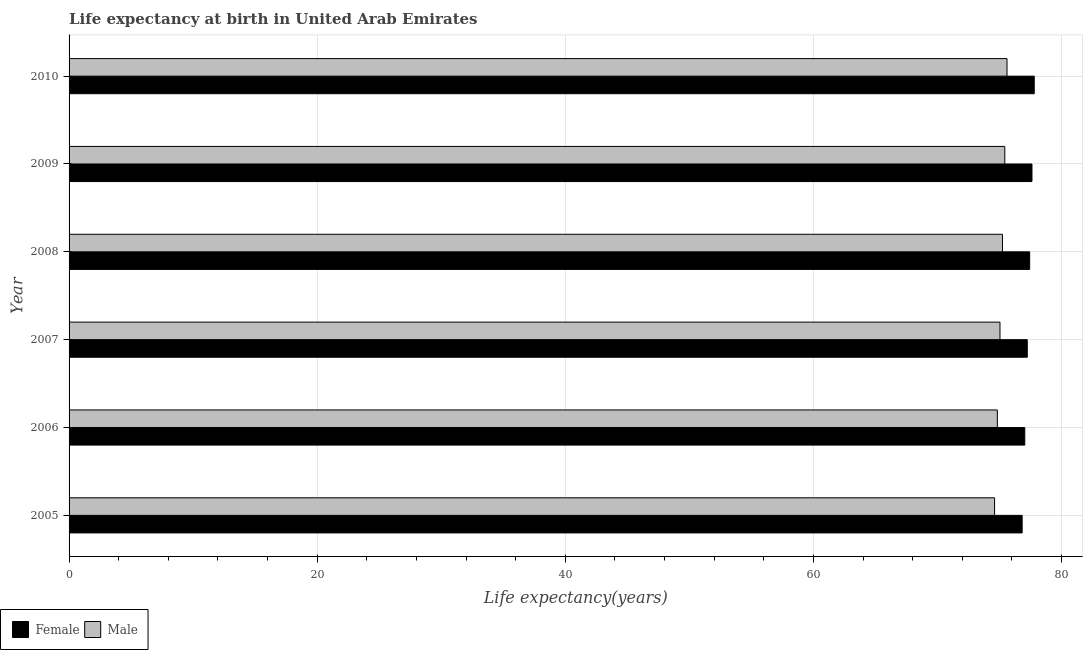In how many cases, is the number of bars for a given year not equal to the number of legend labels?
Make the answer very short. 0. What is the life expectancy(male) in 2008?
Provide a short and direct response. 75.24. Across all years, what is the maximum life expectancy(male)?
Ensure brevity in your answer.  75.61. Across all years, what is the minimum life expectancy(male)?
Make the answer very short. 74.6. In which year was the life expectancy(male) maximum?
Keep it short and to the point. 2010. In which year was the life expectancy(male) minimum?
Give a very brief answer. 2005. What is the total life expectancy(female) in the graph?
Offer a terse response. 463.95. What is the difference between the life expectancy(male) in 2005 and that in 2006?
Make the answer very short. -0.22. What is the difference between the life expectancy(male) in 2006 and the life expectancy(female) in 2007?
Keep it short and to the point. -2.41. What is the average life expectancy(male) per year?
Keep it short and to the point. 75.12. In the year 2005, what is the difference between the life expectancy(male) and life expectancy(female)?
Ensure brevity in your answer.  -2.22. In how many years, is the life expectancy(male) greater than 68 years?
Your answer should be compact. 6. What is the ratio of the life expectancy(female) in 2008 to that in 2010?
Your answer should be compact. 0.99. Is the life expectancy(female) in 2006 less than that in 2010?
Ensure brevity in your answer.  Yes. Is the difference between the life expectancy(female) in 2006 and 2008 greater than the difference between the life expectancy(male) in 2006 and 2008?
Your response must be concise. Yes. What is the difference between the highest and the second highest life expectancy(male)?
Keep it short and to the point. 0.18. What is the difference between the highest and the lowest life expectancy(male)?
Ensure brevity in your answer.  1. In how many years, is the life expectancy(female) greater than the average life expectancy(female) taken over all years?
Provide a succinct answer. 3. Is the sum of the life expectancy(female) in 2005 and 2008 greater than the maximum life expectancy(male) across all years?
Your response must be concise. Yes. How many bars are there?
Provide a succinct answer. 12. Are all the bars in the graph horizontal?
Ensure brevity in your answer.  Yes. How many years are there in the graph?
Provide a succinct answer. 6. Does the graph contain any zero values?
Make the answer very short. No. Does the graph contain grids?
Offer a terse response. Yes. How many legend labels are there?
Make the answer very short. 2. What is the title of the graph?
Your response must be concise. Life expectancy at birth in United Arab Emirates. What is the label or title of the X-axis?
Provide a short and direct response. Life expectancy(years). What is the Life expectancy(years) of Female in 2005?
Offer a very short reply. 76.83. What is the Life expectancy(years) of Male in 2005?
Give a very brief answer. 74.6. What is the Life expectancy(years) of Female in 2006?
Offer a terse response. 77.04. What is the Life expectancy(years) of Male in 2006?
Provide a short and direct response. 74.83. What is the Life expectancy(years) in Female in 2007?
Offer a very short reply. 77.24. What is the Life expectancy(years) in Male in 2007?
Provide a succinct answer. 75.04. What is the Life expectancy(years) of Female in 2008?
Provide a succinct answer. 77.43. What is the Life expectancy(years) in Male in 2008?
Offer a very short reply. 75.24. What is the Life expectancy(years) of Female in 2009?
Ensure brevity in your answer.  77.62. What is the Life expectancy(years) of Male in 2009?
Provide a short and direct response. 75.43. What is the Life expectancy(years) of Female in 2010?
Your answer should be very brief. 77.8. What is the Life expectancy(years) in Male in 2010?
Make the answer very short. 75.61. Across all years, what is the maximum Life expectancy(years) in Female?
Your response must be concise. 77.8. Across all years, what is the maximum Life expectancy(years) in Male?
Offer a terse response. 75.61. Across all years, what is the minimum Life expectancy(years) of Female?
Your answer should be compact. 76.83. Across all years, what is the minimum Life expectancy(years) in Male?
Make the answer very short. 74.6. What is the total Life expectancy(years) of Female in the graph?
Make the answer very short. 463.95. What is the total Life expectancy(years) of Male in the graph?
Offer a terse response. 450.74. What is the difference between the Life expectancy(years) of Female in 2005 and that in 2006?
Offer a very short reply. -0.21. What is the difference between the Life expectancy(years) of Male in 2005 and that in 2006?
Keep it short and to the point. -0.22. What is the difference between the Life expectancy(years) of Female in 2005 and that in 2007?
Give a very brief answer. -0.41. What is the difference between the Life expectancy(years) of Male in 2005 and that in 2007?
Give a very brief answer. -0.44. What is the difference between the Life expectancy(years) of Female in 2005 and that in 2008?
Your response must be concise. -0.61. What is the difference between the Life expectancy(years) in Male in 2005 and that in 2008?
Offer a very short reply. -0.64. What is the difference between the Life expectancy(years) of Female in 2005 and that in 2009?
Keep it short and to the point. -0.79. What is the difference between the Life expectancy(years) of Male in 2005 and that in 2009?
Your answer should be very brief. -0.82. What is the difference between the Life expectancy(years) of Female in 2005 and that in 2010?
Your answer should be compact. -0.97. What is the difference between the Life expectancy(years) of Male in 2005 and that in 2010?
Offer a terse response. -1. What is the difference between the Life expectancy(years) of Female in 2006 and that in 2007?
Offer a terse response. -0.2. What is the difference between the Life expectancy(years) in Male in 2006 and that in 2007?
Keep it short and to the point. -0.21. What is the difference between the Life expectancy(years) in Female in 2006 and that in 2008?
Offer a terse response. -0.39. What is the difference between the Life expectancy(years) of Male in 2006 and that in 2008?
Your response must be concise. -0.41. What is the difference between the Life expectancy(years) in Female in 2006 and that in 2009?
Make the answer very short. -0.58. What is the difference between the Life expectancy(years) in Male in 2006 and that in 2009?
Give a very brief answer. -0.6. What is the difference between the Life expectancy(years) of Female in 2006 and that in 2010?
Provide a short and direct response. -0.76. What is the difference between the Life expectancy(years) in Male in 2006 and that in 2010?
Offer a terse response. -0.78. What is the difference between the Life expectancy(years) in Female in 2007 and that in 2008?
Keep it short and to the point. -0.19. What is the difference between the Life expectancy(years) of Male in 2007 and that in 2008?
Offer a terse response. -0.2. What is the difference between the Life expectancy(years) in Female in 2007 and that in 2009?
Your answer should be compact. -0.38. What is the difference between the Life expectancy(years) of Male in 2007 and that in 2009?
Give a very brief answer. -0.39. What is the difference between the Life expectancy(years) of Female in 2007 and that in 2010?
Offer a terse response. -0.56. What is the difference between the Life expectancy(years) of Male in 2007 and that in 2010?
Keep it short and to the point. -0.57. What is the difference between the Life expectancy(years) of Female in 2008 and that in 2009?
Provide a short and direct response. -0.19. What is the difference between the Life expectancy(years) of Male in 2008 and that in 2009?
Give a very brief answer. -0.19. What is the difference between the Life expectancy(years) in Female in 2008 and that in 2010?
Give a very brief answer. -0.37. What is the difference between the Life expectancy(years) in Male in 2008 and that in 2010?
Provide a succinct answer. -0.37. What is the difference between the Life expectancy(years) in Female in 2009 and that in 2010?
Keep it short and to the point. -0.18. What is the difference between the Life expectancy(years) of Male in 2009 and that in 2010?
Keep it short and to the point. -0.18. What is the difference between the Life expectancy(years) in Female in 2005 and the Life expectancy(years) in Male in 2006?
Your answer should be compact. 2. What is the difference between the Life expectancy(years) in Female in 2005 and the Life expectancy(years) in Male in 2007?
Make the answer very short. 1.79. What is the difference between the Life expectancy(years) of Female in 2005 and the Life expectancy(years) of Male in 2008?
Make the answer very short. 1.59. What is the difference between the Life expectancy(years) in Female in 2005 and the Life expectancy(years) in Male in 2009?
Ensure brevity in your answer.  1.4. What is the difference between the Life expectancy(years) in Female in 2005 and the Life expectancy(years) in Male in 2010?
Your answer should be very brief. 1.22. What is the difference between the Life expectancy(years) in Female in 2006 and the Life expectancy(years) in Male in 2007?
Make the answer very short. 2. What is the difference between the Life expectancy(years) in Female in 2006 and the Life expectancy(years) in Male in 2008?
Make the answer very short. 1.8. What is the difference between the Life expectancy(years) of Female in 2006 and the Life expectancy(years) of Male in 2009?
Make the answer very short. 1.61. What is the difference between the Life expectancy(years) of Female in 2006 and the Life expectancy(years) of Male in 2010?
Ensure brevity in your answer.  1.43. What is the difference between the Life expectancy(years) in Female in 2007 and the Life expectancy(years) in Male in 2008?
Provide a succinct answer. 2. What is the difference between the Life expectancy(years) of Female in 2007 and the Life expectancy(years) of Male in 2009?
Ensure brevity in your answer.  1.81. What is the difference between the Life expectancy(years) in Female in 2007 and the Life expectancy(years) in Male in 2010?
Provide a short and direct response. 1.63. What is the difference between the Life expectancy(years) of Female in 2008 and the Life expectancy(years) of Male in 2009?
Make the answer very short. 2. What is the difference between the Life expectancy(years) in Female in 2008 and the Life expectancy(years) in Male in 2010?
Your response must be concise. 1.83. What is the difference between the Life expectancy(years) in Female in 2009 and the Life expectancy(years) in Male in 2010?
Your response must be concise. 2.01. What is the average Life expectancy(years) of Female per year?
Give a very brief answer. 77.32. What is the average Life expectancy(years) of Male per year?
Provide a short and direct response. 75.12. In the year 2005, what is the difference between the Life expectancy(years) in Female and Life expectancy(years) in Male?
Ensure brevity in your answer.  2.22. In the year 2006, what is the difference between the Life expectancy(years) of Female and Life expectancy(years) of Male?
Your response must be concise. 2.21. In the year 2008, what is the difference between the Life expectancy(years) in Female and Life expectancy(years) in Male?
Offer a terse response. 2.19. In the year 2009, what is the difference between the Life expectancy(years) in Female and Life expectancy(years) in Male?
Your response must be concise. 2.19. In the year 2010, what is the difference between the Life expectancy(years) in Female and Life expectancy(years) in Male?
Your answer should be compact. 2.19. What is the ratio of the Life expectancy(years) in Male in 2005 to that in 2007?
Give a very brief answer. 0.99. What is the ratio of the Life expectancy(years) of Male in 2005 to that in 2008?
Your answer should be compact. 0.99. What is the ratio of the Life expectancy(years) in Female in 2005 to that in 2009?
Your answer should be compact. 0.99. What is the ratio of the Life expectancy(years) of Male in 2005 to that in 2009?
Provide a succinct answer. 0.99. What is the ratio of the Life expectancy(years) in Female in 2005 to that in 2010?
Your answer should be compact. 0.99. What is the ratio of the Life expectancy(years) of Male in 2005 to that in 2010?
Your answer should be very brief. 0.99. What is the ratio of the Life expectancy(years) in Male in 2006 to that in 2007?
Offer a terse response. 1. What is the ratio of the Life expectancy(years) in Female in 2006 to that in 2008?
Make the answer very short. 0.99. What is the ratio of the Life expectancy(years) in Female in 2006 to that in 2010?
Offer a terse response. 0.99. What is the ratio of the Life expectancy(years) in Female in 2007 to that in 2008?
Give a very brief answer. 1. What is the ratio of the Life expectancy(years) of Male in 2007 to that in 2008?
Give a very brief answer. 1. What is the ratio of the Life expectancy(years) in Male in 2007 to that in 2009?
Offer a very short reply. 0.99. What is the ratio of the Life expectancy(years) in Female in 2008 to that in 2009?
Provide a succinct answer. 1. What is the ratio of the Life expectancy(years) of Male in 2008 to that in 2009?
Make the answer very short. 1. What is the ratio of the Life expectancy(years) of Male in 2008 to that in 2010?
Your response must be concise. 1. What is the ratio of the Life expectancy(years) of Female in 2009 to that in 2010?
Offer a terse response. 1. What is the difference between the highest and the second highest Life expectancy(years) in Female?
Ensure brevity in your answer.  0.18. What is the difference between the highest and the second highest Life expectancy(years) of Male?
Provide a short and direct response. 0.18. What is the difference between the highest and the lowest Life expectancy(years) of Female?
Offer a very short reply. 0.97. What is the difference between the highest and the lowest Life expectancy(years) in Male?
Offer a very short reply. 1. 